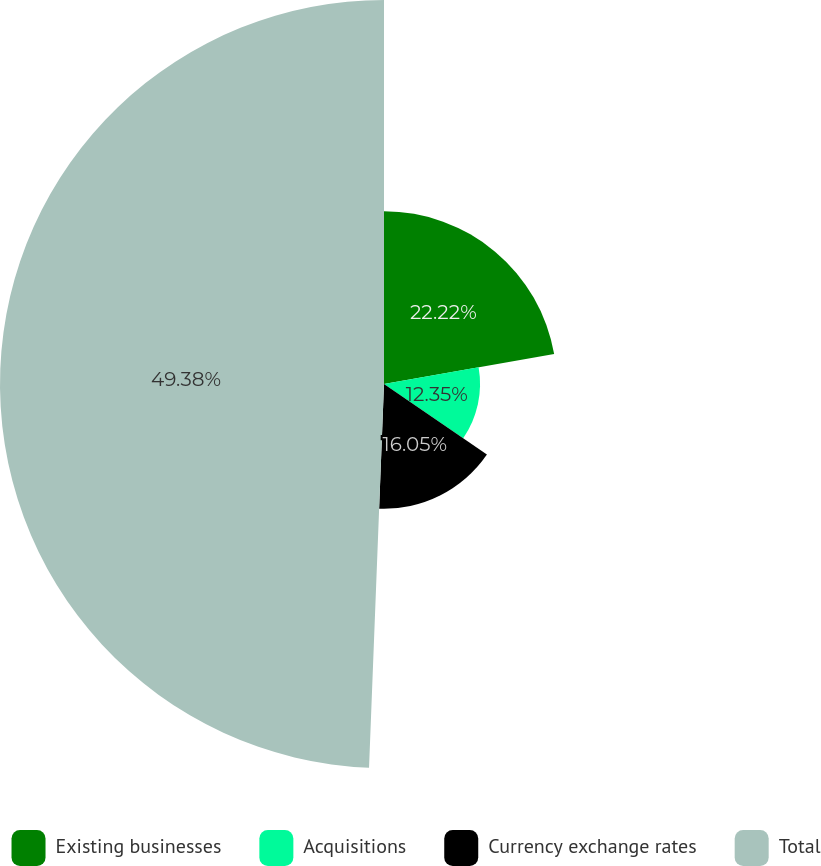Convert chart to OTSL. <chart><loc_0><loc_0><loc_500><loc_500><pie_chart><fcel>Existing businesses<fcel>Acquisitions<fcel>Currency exchange rates<fcel>Total<nl><fcel>22.22%<fcel>12.35%<fcel>16.05%<fcel>49.38%<nl></chart> 